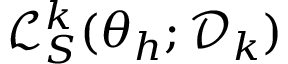Convert formula to latex. <formula><loc_0><loc_0><loc_500><loc_500>\mathcal { L } _ { S } ^ { k } ( \theta _ { h } ; \mathcal { D } _ { k } )</formula> 